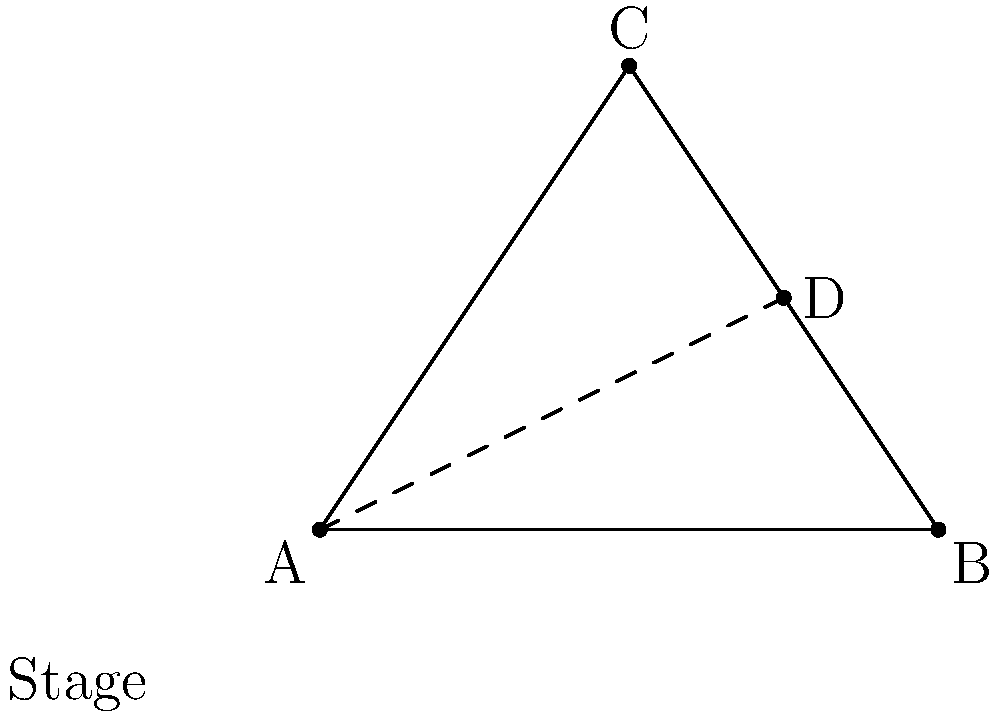During your recent Southern soul-inspired concert, you used a triangular stage lighting arrangement. If the base of the triangle is 4 meters wide and the height is 3 meters, what is the length of the line connecting the apex of the triangle to the midpoint of the opposite side? Let's approach this step-by-step:

1) The triangle formed by the stage lights has a base of 4 meters and a height of 3 meters.

2) The midpoint of the base is located at (2,0) if we consider the left corner as the origin (0,0).

3) The apex of the triangle is at (2,3).

4) We need to find the distance between these two points: (2,0) and (2,3).

5) We can use the distance formula: 
   $$d = \sqrt{(x_2-x_1)^2 + (y_2-y_1)^2}$$

6) Plugging in our values:
   $$d = \sqrt{(2-2)^2 + (3-0)^2}$$

7) Simplifying:
   $$d = \sqrt{0^2 + 3^2} = \sqrt{9} = 3$$

Therefore, the length of the line connecting the apex to the midpoint of the base is 3 meters.
Answer: 3 meters 